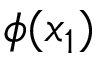Convert formula to latex. <formula><loc_0><loc_0><loc_500><loc_500>\phi ( x _ { 1 } )</formula> 